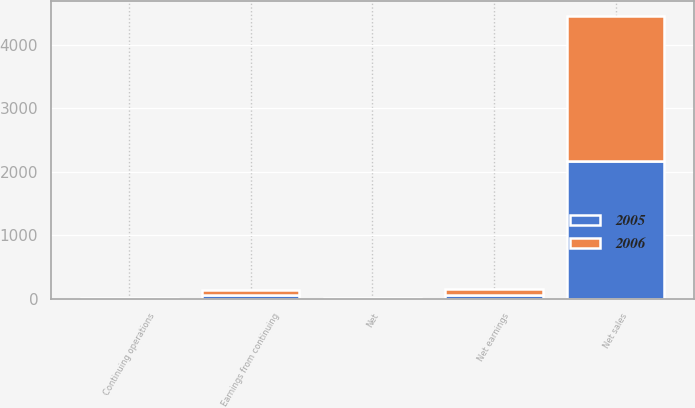<chart> <loc_0><loc_0><loc_500><loc_500><stacked_bar_chart><ecel><fcel>Net sales<fcel>Earnings from continuing<fcel>Net earnings<fcel>Continuing operations<fcel>Net<nl><fcel>2006<fcel>2290.8<fcel>80.2<fcel>80.2<fcel>2.64<fcel>2.64<nl><fcel>2005<fcel>2167.3<fcel>64.6<fcel>66<fcel>2.17<fcel>2.22<nl></chart> 